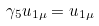<formula> <loc_0><loc_0><loc_500><loc_500>\gamma _ { 5 } u _ { 1 \mu } = u _ { 1 \mu }</formula> 